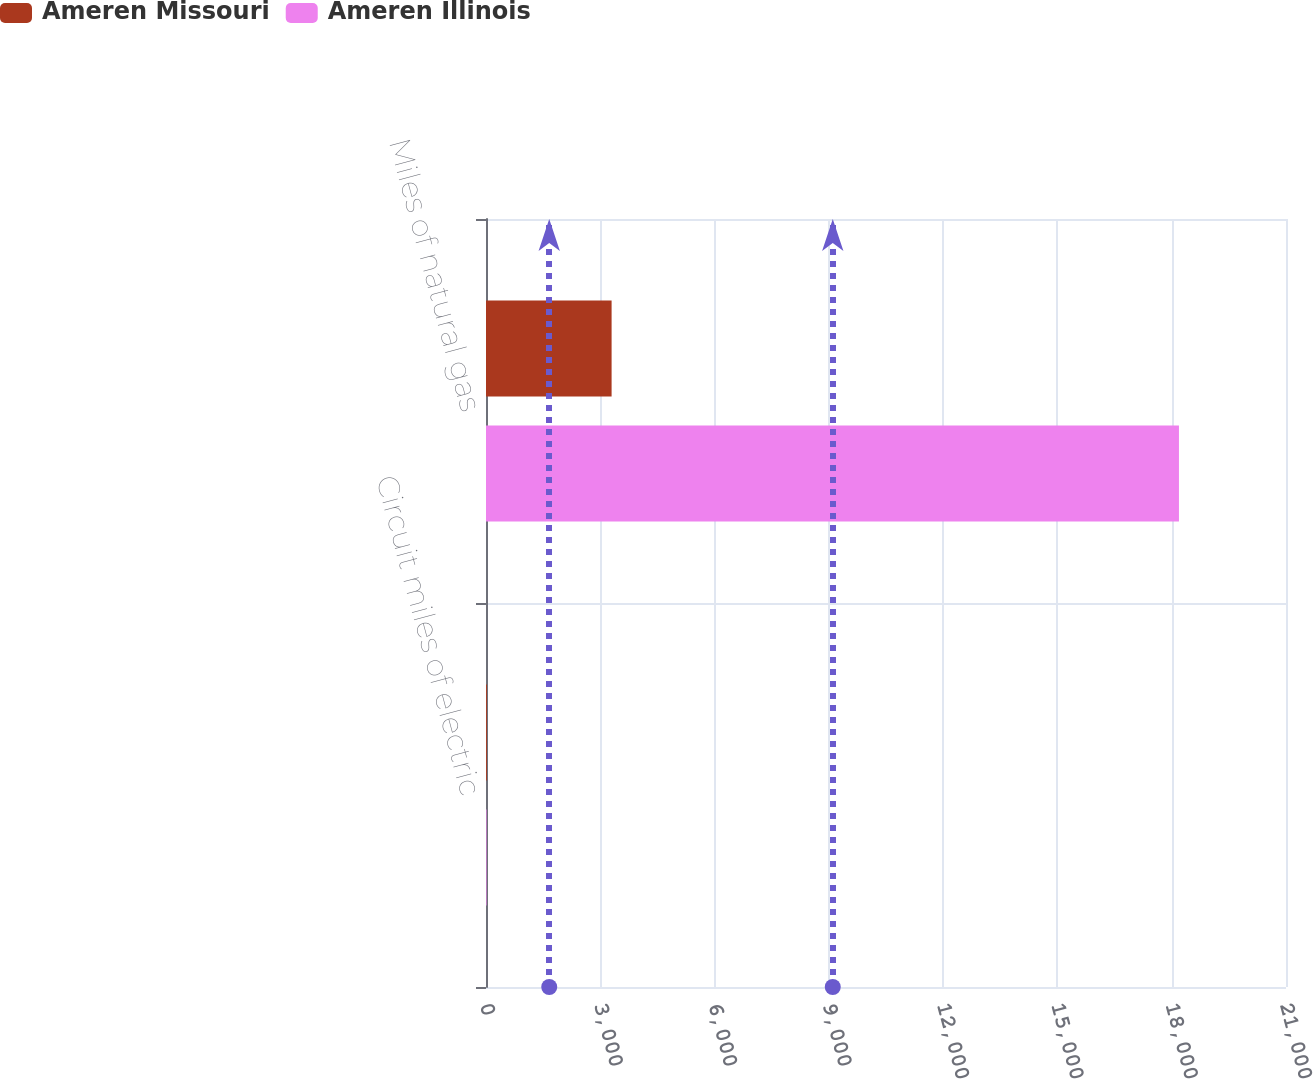Convert chart. <chart><loc_0><loc_0><loc_500><loc_500><stacked_bar_chart><ecel><fcel>Circuit miles of electric<fcel>Miles of natural gas<nl><fcel>Ameren Missouri<fcel>23<fcel>3297<nl><fcel>Ameren Illinois<fcel>15<fcel>18190<nl></chart> 